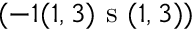Convert formula to latex. <formula><loc_0><loc_0><loc_500><loc_500>( - 1 ( 1 , 3 ) s ( 1 , 3 ) )</formula> 